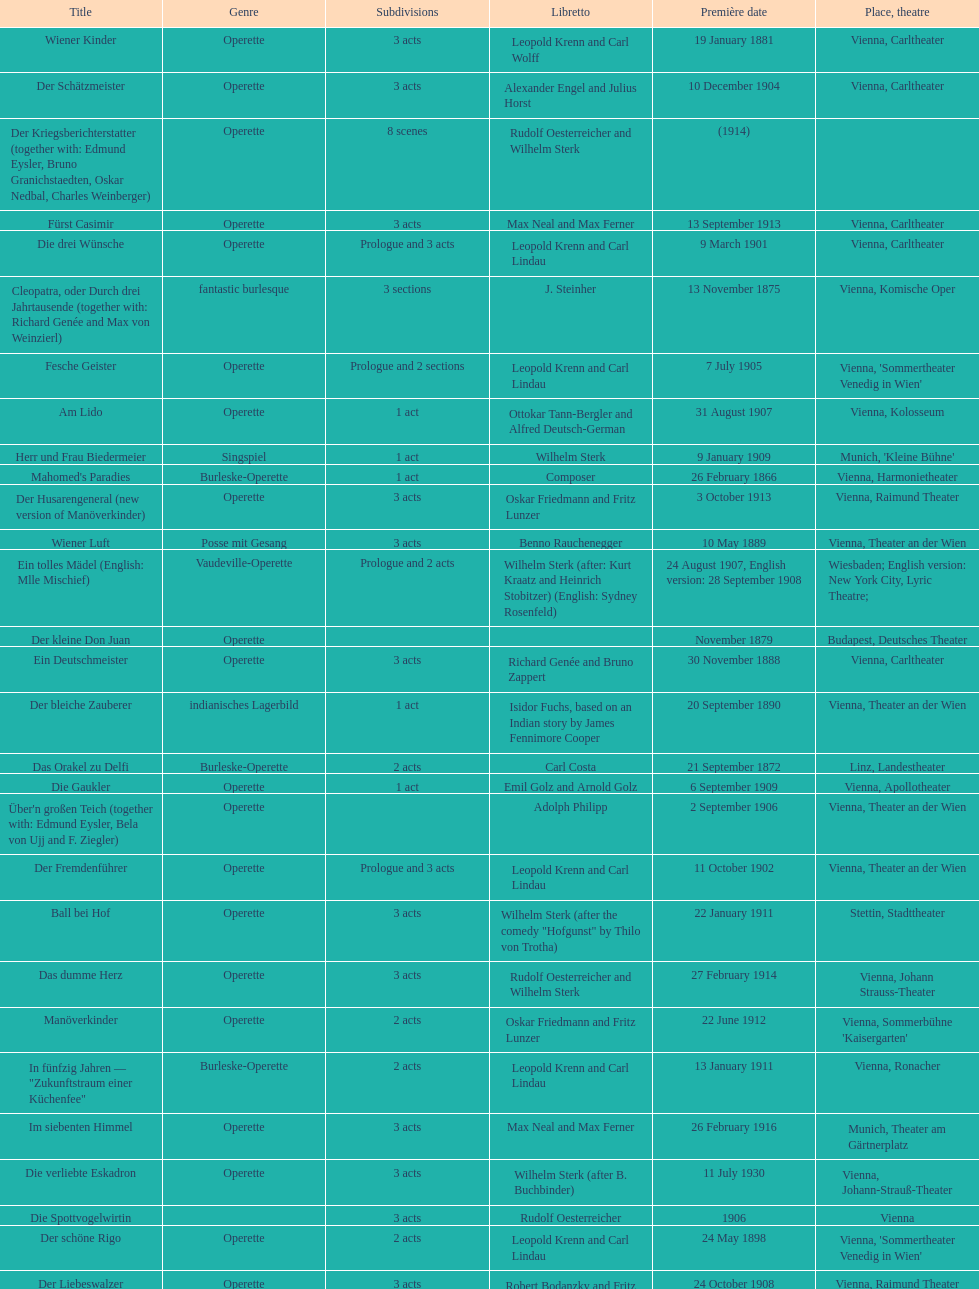Which year did he release his last operetta? 1930. 